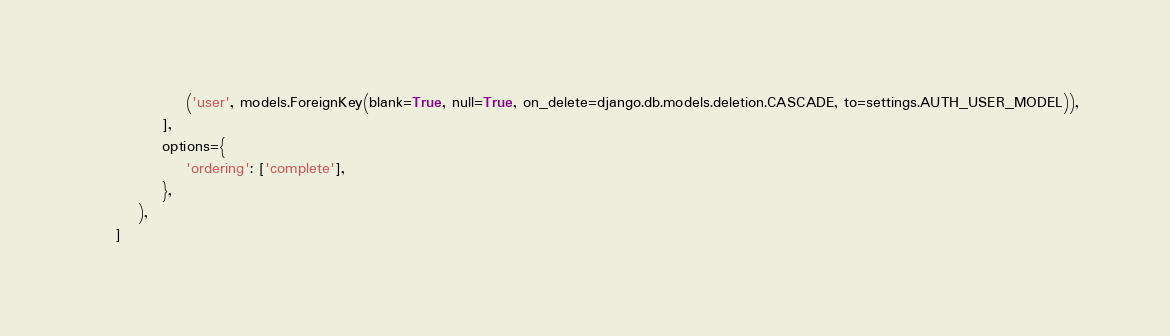Convert code to text. <code><loc_0><loc_0><loc_500><loc_500><_Python_>                ('user', models.ForeignKey(blank=True, null=True, on_delete=django.db.models.deletion.CASCADE, to=settings.AUTH_USER_MODEL)),
            ],
            options={
                'ordering': ['complete'],
            },
        ),
    ]
</code> 